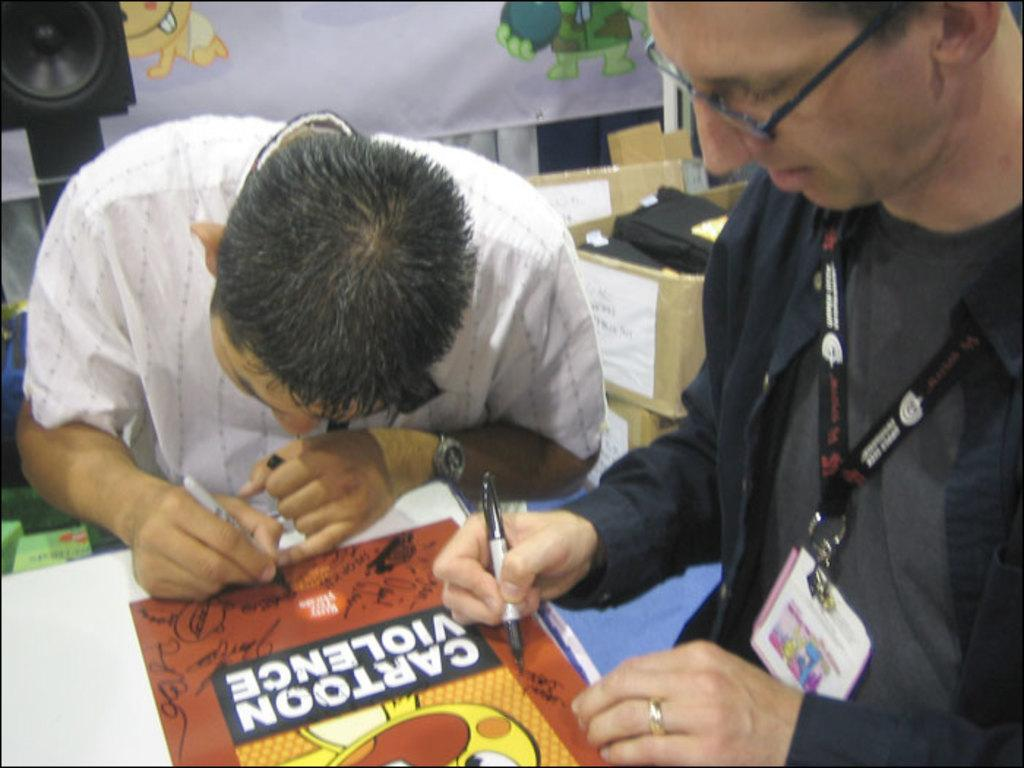How many people are present in the image? There are two people in the image. What are the two people doing? The two people are holding pens and writing on paper. What can be seen in the background of the image? There is a speaker and a cloth in the background of the image. What else is visible in the image besides the people and the background? There are boxes in the image. What type of holiday is being celebrated in the image? There is no indication of a holiday being celebrated in the image. How many legs can be seen in the image? The image only shows two people, and it is not possible to determine the number of legs visible from the provided facts. 